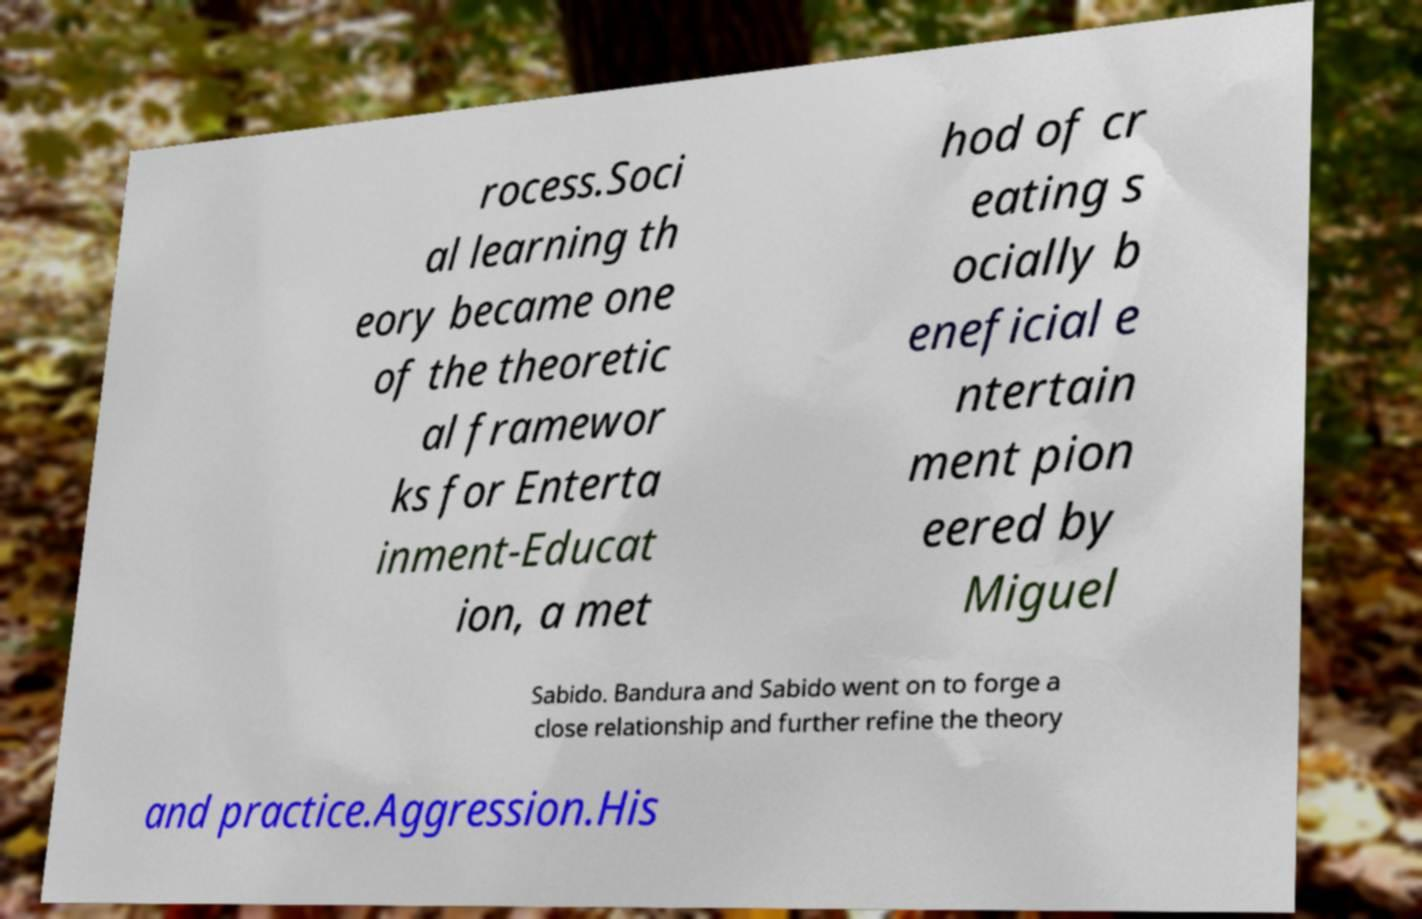I need the written content from this picture converted into text. Can you do that? rocess.Soci al learning th eory became one of the theoretic al framewor ks for Enterta inment-Educat ion, a met hod of cr eating s ocially b eneficial e ntertain ment pion eered by Miguel Sabido. Bandura and Sabido went on to forge a close relationship and further refine the theory and practice.Aggression.His 